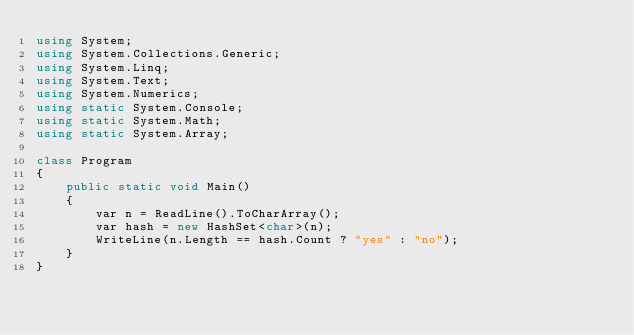<code> <loc_0><loc_0><loc_500><loc_500><_C#_>using System;
using System.Collections.Generic;
using System.Linq;
using System.Text;
using System.Numerics;
using static System.Console;
using static System.Math;
using static System.Array;

class Program
{
    public static void Main()
    {
        var n = ReadLine().ToCharArray();
        var hash = new HashSet<char>(n);
        WriteLine(n.Length == hash.Count ? "yes" : "no");
    }
}
</code> 